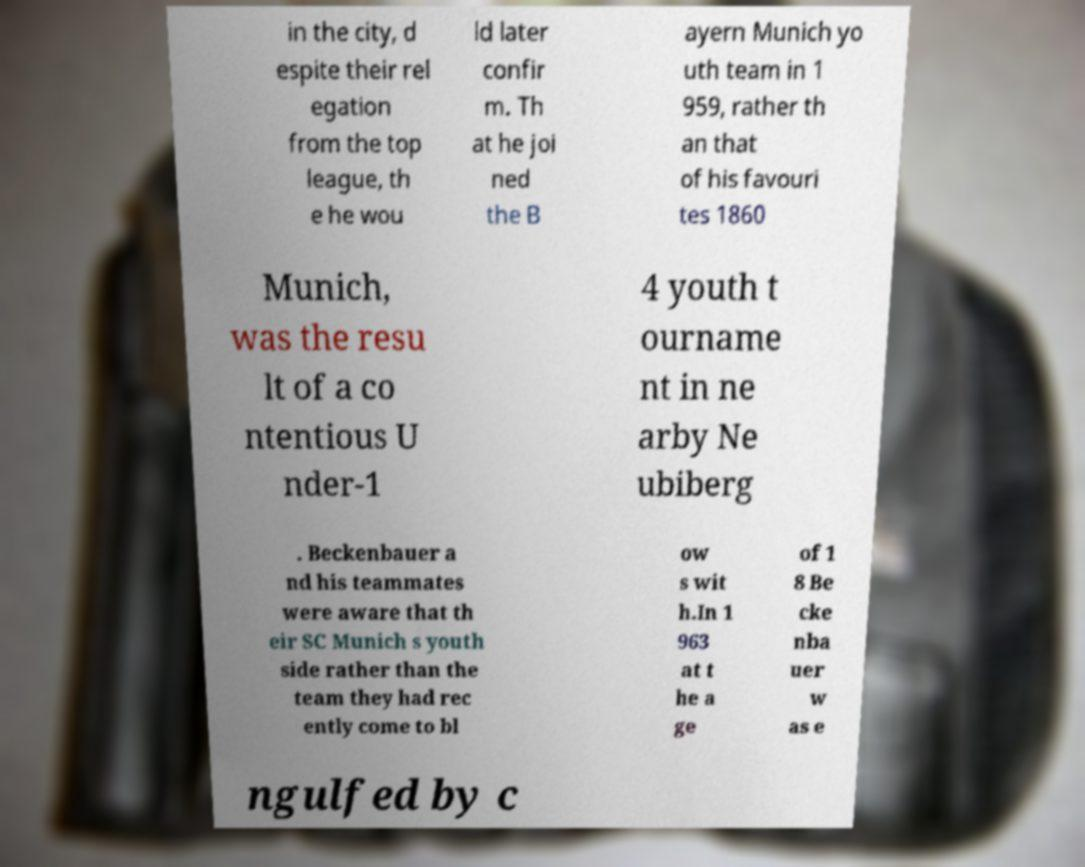Could you extract and type out the text from this image? in the city, d espite their rel egation from the top league, th e he wou ld later confir m. Th at he joi ned the B ayern Munich yo uth team in 1 959, rather th an that of his favouri tes 1860 Munich, was the resu lt of a co ntentious U nder-1 4 youth t ourname nt in ne arby Ne ubiberg . Beckenbauer a nd his teammates were aware that th eir SC Munich s youth side rather than the team they had rec ently come to bl ow s wit h.In 1 963 at t he a ge of 1 8 Be cke nba uer w as e ngulfed by c 